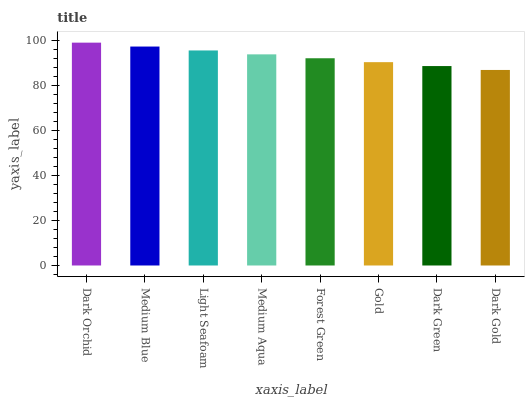Is Dark Gold the minimum?
Answer yes or no. Yes. Is Dark Orchid the maximum?
Answer yes or no. Yes. Is Medium Blue the minimum?
Answer yes or no. No. Is Medium Blue the maximum?
Answer yes or no. No. Is Dark Orchid greater than Medium Blue?
Answer yes or no. Yes. Is Medium Blue less than Dark Orchid?
Answer yes or no. Yes. Is Medium Blue greater than Dark Orchid?
Answer yes or no. No. Is Dark Orchid less than Medium Blue?
Answer yes or no. No. Is Medium Aqua the high median?
Answer yes or no. Yes. Is Forest Green the low median?
Answer yes or no. Yes. Is Gold the high median?
Answer yes or no. No. Is Medium Aqua the low median?
Answer yes or no. No. 